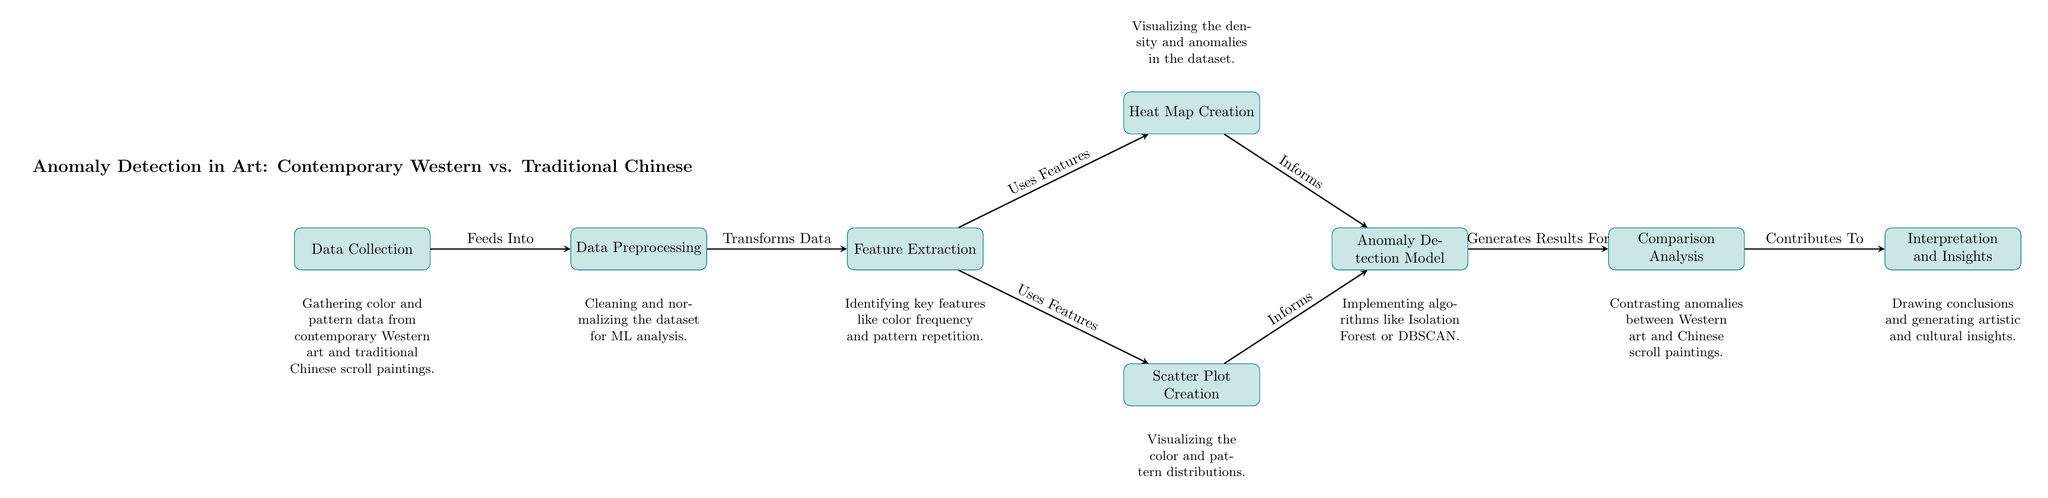What's the first step in the anomaly detection process? The diagram indicates that the first step is 'Data Collection,' as shown at the leftmost part of the diagram.
Answer: Data Collection How many main processes are depicted in the diagram? Counting each of the nodes that represent a process, there are a total of eight main processes depicted in the diagram.
Answer: Eight What do the arrows between 'Data Preprocessing' and 'Feature Extraction' signify? The arrows indicate the flow of the process, showing that 'Data Preprocessing' feeds into 'Feature Extraction,' meaning the output of the former transforms into input for the latter.
Answer: Feeds Into Which two processes inform the 'Anomaly Detection Model'? The processes that inform the 'Anomaly Detection Model' are 'Scatter Plot Creation' and 'Heat Map Creation,' as indicated by the arrows leading into the 'Anomaly Detection Model'.
Answer: Scatter Plot Creation and Heat Map Creation What is the last step of the anomaly detection analysis? According to the diagram, the last step is ‘Interpretation and Insights,’ positioned as the rightmost node, which represents the concluding process of the analysis flow.
Answer: Interpretation and Insights Which techniques are suggested for anomaly detection? The diagram mentions implementing algorithms like 'Isolation Forest or DBSCAN' as techniques for the anomaly detection model process.
Answer: Isolation Forest or DBSCAN How does ‘Comparison Analysis’ relate to ‘Anomaly Detection Model’? The ‘Comparison Analysis’ is directly fed by results from the ‘Anomaly Detection Model,’ indicating that it generates results that are analyzed for comparison purposes between different art styles.
Answer: Generates Results For Which process visualizes the density in the dataset? The process that focuses on visualizing the density and anomalies in the dataset is 'Heat Map Creation,' as illustrated in the diagram flow above the ‘Scatter Plot Creation.’
Answer: Heat Map Creation 